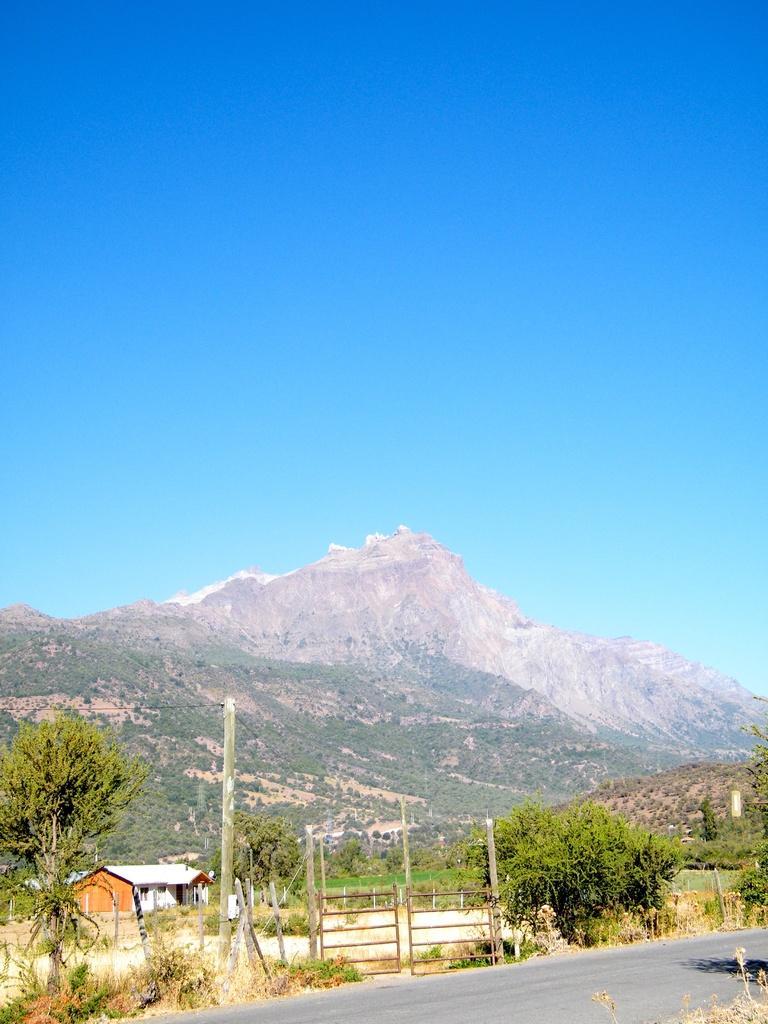In one or two sentences, can you explain what this image depicts? This image is taken outdoors. At the top of the image there is the sky. In the background there is a hill. There are many trees and plants. At the bottom of the image there is a road. In the middle of the image there is a house. There are few trees and plants. There is a pole and there is a gate. 